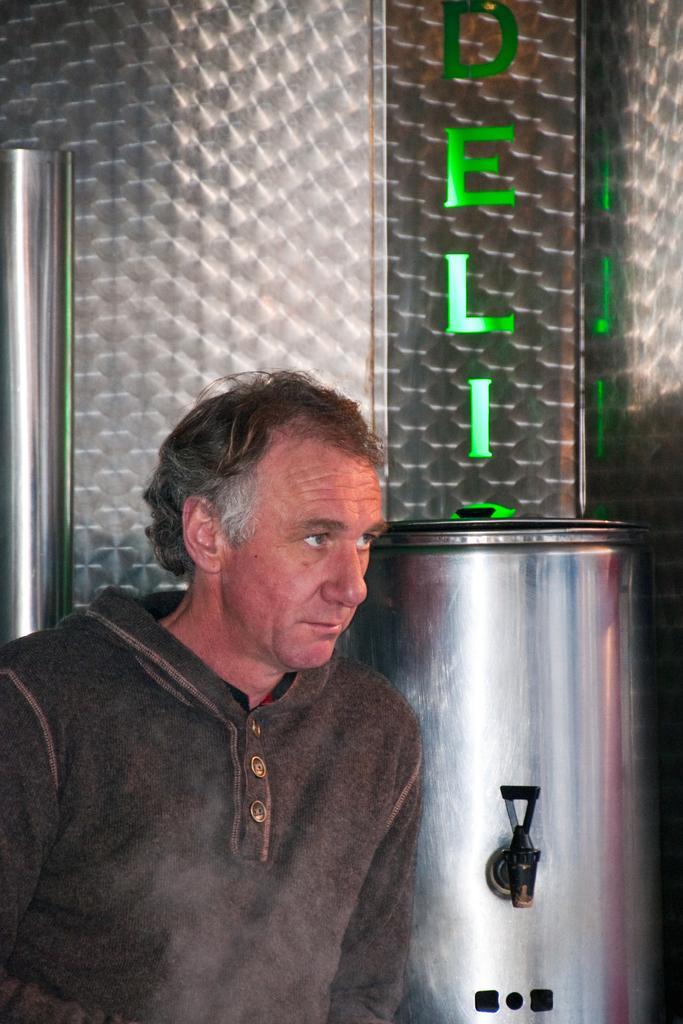How would you summarize this image in a sentence or two? In the image we can see a man wearing clothes. Here we can see metal container, metal wall and LED text. 